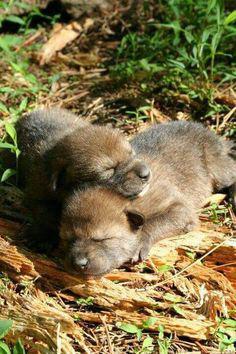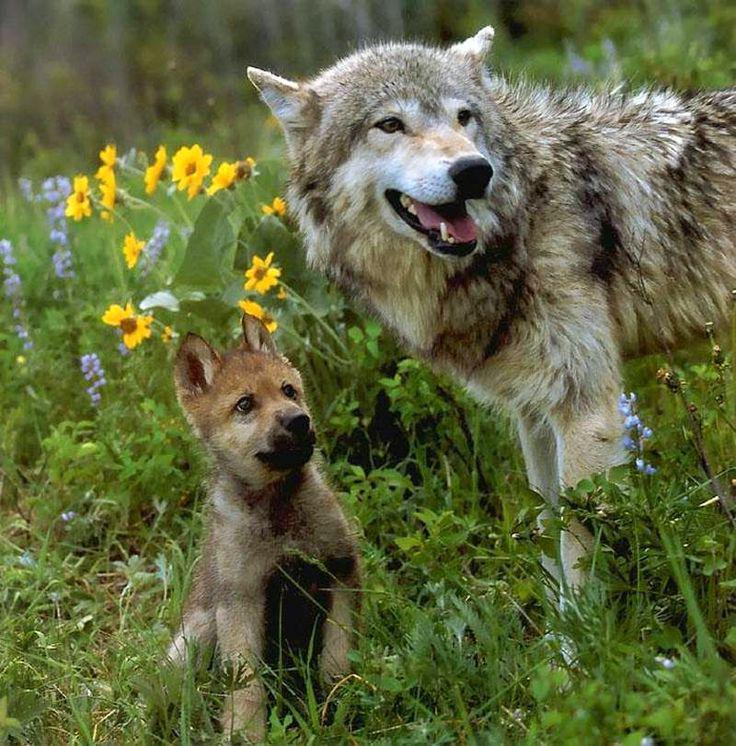The first image is the image on the left, the second image is the image on the right. Considering the images on both sides, is "The left image contains two baby wolves laying down together." valid? Answer yes or no. Yes. 